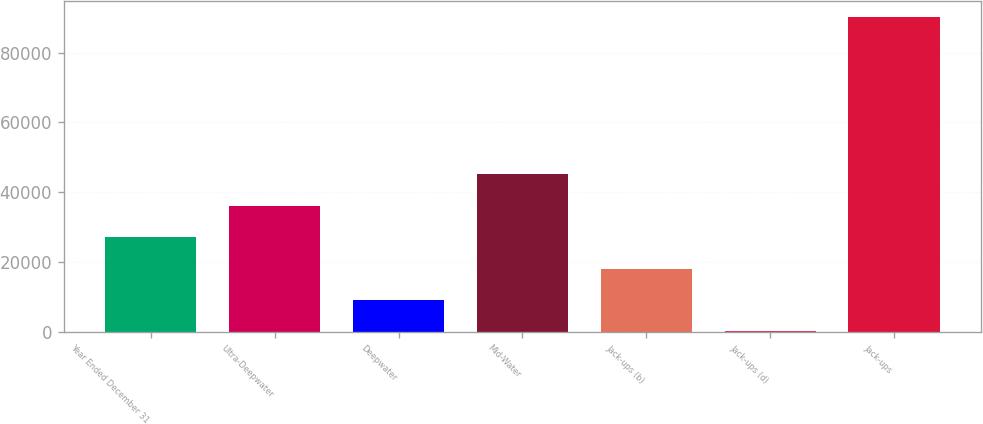Convert chart. <chart><loc_0><loc_0><loc_500><loc_500><bar_chart><fcel>Year Ended December 31<fcel>Ultra-Deepwater<fcel>Deepwater<fcel>Mid-Water<fcel>Jack-ups (b)<fcel>Jack-ups (d)<fcel>Jack-ups<nl><fcel>27097.1<fcel>36111.8<fcel>9067.7<fcel>45126.5<fcel>18082.4<fcel>53<fcel>90200<nl></chart> 